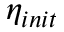<formula> <loc_0><loc_0><loc_500><loc_500>\eta _ { i n i t }</formula> 